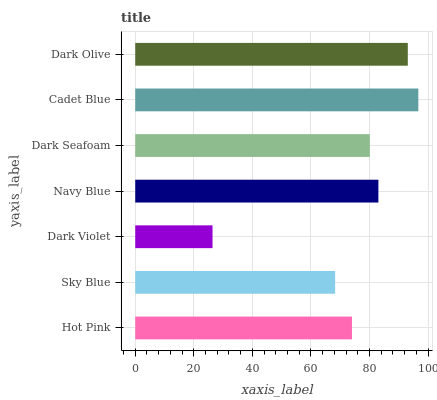Is Dark Violet the minimum?
Answer yes or no. Yes. Is Cadet Blue the maximum?
Answer yes or no. Yes. Is Sky Blue the minimum?
Answer yes or no. No. Is Sky Blue the maximum?
Answer yes or no. No. Is Hot Pink greater than Sky Blue?
Answer yes or no. Yes. Is Sky Blue less than Hot Pink?
Answer yes or no. Yes. Is Sky Blue greater than Hot Pink?
Answer yes or no. No. Is Hot Pink less than Sky Blue?
Answer yes or no. No. Is Dark Seafoam the high median?
Answer yes or no. Yes. Is Dark Seafoam the low median?
Answer yes or no. Yes. Is Sky Blue the high median?
Answer yes or no. No. Is Cadet Blue the low median?
Answer yes or no. No. 